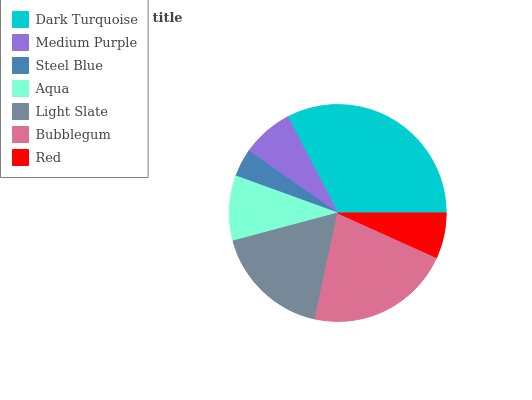Is Steel Blue the minimum?
Answer yes or no. Yes. Is Dark Turquoise the maximum?
Answer yes or no. Yes. Is Medium Purple the minimum?
Answer yes or no. No. Is Medium Purple the maximum?
Answer yes or no. No. Is Dark Turquoise greater than Medium Purple?
Answer yes or no. Yes. Is Medium Purple less than Dark Turquoise?
Answer yes or no. Yes. Is Medium Purple greater than Dark Turquoise?
Answer yes or no. No. Is Dark Turquoise less than Medium Purple?
Answer yes or no. No. Is Aqua the high median?
Answer yes or no. Yes. Is Aqua the low median?
Answer yes or no. Yes. Is Bubblegum the high median?
Answer yes or no. No. Is Steel Blue the low median?
Answer yes or no. No. 